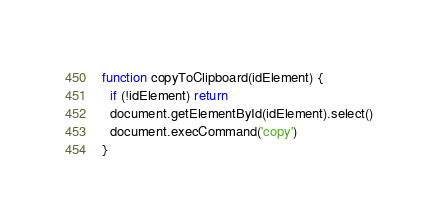<code> <loc_0><loc_0><loc_500><loc_500><_JavaScript_>function copyToClipboard(idElement) {
  if (!idElement) return
  document.getElementById(idElement).select()
  document.execCommand('copy')
}</code> 